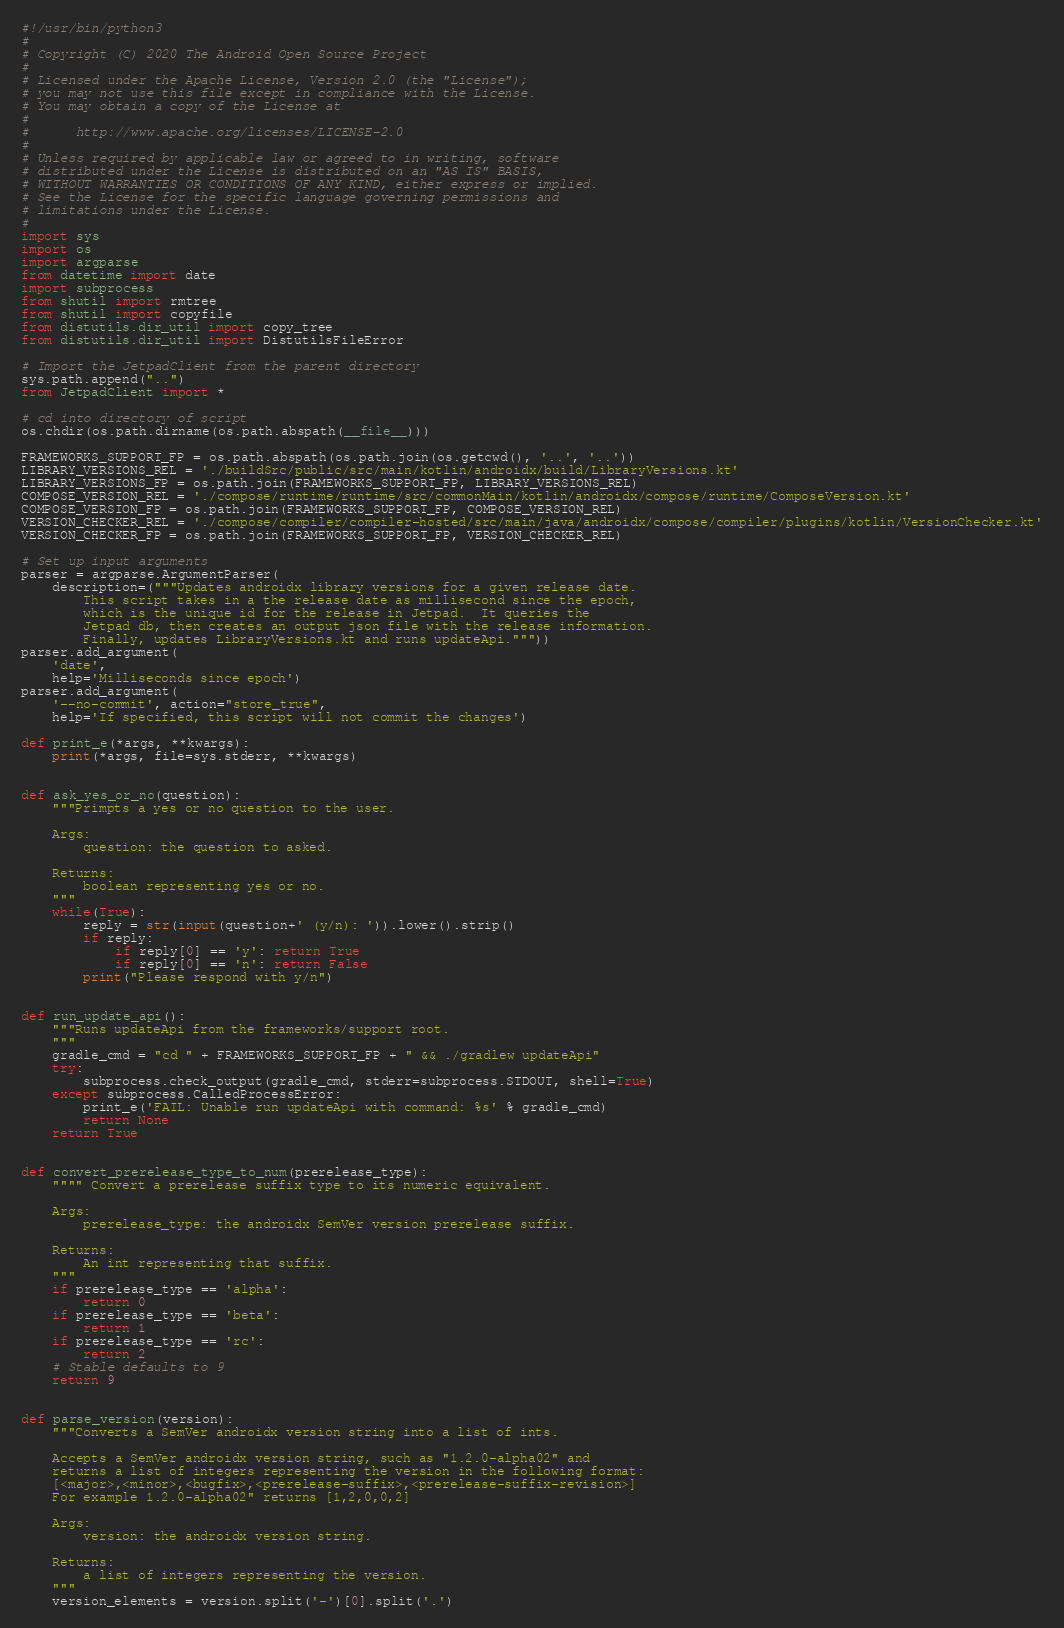Convert code to text. <code><loc_0><loc_0><loc_500><loc_500><_Python_>#!/usr/bin/python3
#
# Copyright (C) 2020 The Android Open Source Project
#
# Licensed under the Apache License, Version 2.0 (the "License");
# you may not use this file except in compliance with the License.
# You may obtain a copy of the License at
#
#      http://www.apache.org/licenses/LICENSE-2.0
#
# Unless required by applicable law or agreed to in writing, software
# distributed under the License is distributed on an "AS IS" BASIS,
# WITHOUT WARRANTIES OR CONDITIONS OF ANY KIND, either express or implied.
# See the License for the specific language governing permissions and
# limitations under the License.
#
import sys
import os
import argparse
from datetime import date
import subprocess
from shutil import rmtree
from shutil import copyfile
from distutils.dir_util import copy_tree
from distutils.dir_util import DistutilsFileError

# Import the JetpadClient from the parent directory
sys.path.append("..")
from JetpadClient import *

# cd into directory of script
os.chdir(os.path.dirname(os.path.abspath(__file__)))

FRAMEWORKS_SUPPORT_FP = os.path.abspath(os.path.join(os.getcwd(), '..', '..'))
LIBRARY_VERSIONS_REL = './buildSrc/public/src/main/kotlin/androidx/build/LibraryVersions.kt'
LIBRARY_VERSIONS_FP = os.path.join(FRAMEWORKS_SUPPORT_FP, LIBRARY_VERSIONS_REL)
COMPOSE_VERSION_REL = './compose/runtime/runtime/src/commonMain/kotlin/androidx/compose/runtime/ComposeVersion.kt'
COMPOSE_VERSION_FP = os.path.join(FRAMEWORKS_SUPPORT_FP, COMPOSE_VERSION_REL)
VERSION_CHECKER_REL = './compose/compiler/compiler-hosted/src/main/java/androidx/compose/compiler/plugins/kotlin/VersionChecker.kt'
VERSION_CHECKER_FP = os.path.join(FRAMEWORKS_SUPPORT_FP, VERSION_CHECKER_REL)

# Set up input arguments
parser = argparse.ArgumentParser(
    description=("""Updates androidx library versions for a given release date.
        This script takes in a the release date as millisecond since the epoch,
        which is the unique id for the release in Jetpad.  It queries the
        Jetpad db, then creates an output json file with the release information.
        Finally, updates LibraryVersions.kt and runs updateApi."""))
parser.add_argument(
    'date',
    help='Milliseconds since epoch')
parser.add_argument(
    '--no-commit', action="store_true",
    help='If specified, this script will not commit the changes')

def print_e(*args, **kwargs):
    print(*args, file=sys.stderr, **kwargs)


def ask_yes_or_no(question):
    """Primpts a yes or no question to the user.

    Args:
        question: the question to asked.

    Returns:
        boolean representing yes or no.
    """
    while(True):
        reply = str(input(question+' (y/n): ')).lower().strip()
        if reply:
            if reply[0] == 'y': return True
            if reply[0] == 'n': return False
        print("Please respond with y/n")


def run_update_api():
    """Runs updateApi from the frameworks/support root.
    """
    gradle_cmd = "cd " + FRAMEWORKS_SUPPORT_FP + " && ./gradlew updateApi"
    try:
        subprocess.check_output(gradle_cmd, stderr=subprocess.STDOUT, shell=True)
    except subprocess.CalledProcessError:
        print_e('FAIL: Unable run updateApi with command: %s' % gradle_cmd)
        return None
    return True


def convert_prerelease_type_to_num(prerelease_type):
    """" Convert a prerelease suffix type to its numeric equivalent.

    Args:
        prerelease_type: the androidx SemVer version prerelease suffix.

    Returns:
        An int representing that suffix.
    """
    if prerelease_type == 'alpha':
        return 0
    if prerelease_type == 'beta':
        return 1
    if prerelease_type == 'rc':
        return 2
    # Stable defaults to 9
    return 9


def parse_version(version):
    """Converts a SemVer androidx version string into a list of ints.

    Accepts a SemVer androidx version string, such as "1.2.0-alpha02" and
    returns a list of integers representing the version in the following format:
    [<major>,<minor>,<bugfix>,<prerelease-suffix>,<prerelease-suffix-revision>]
    For example 1.2.0-alpha02" returns [1,2,0,0,2]

    Args:
        version: the androidx version string.

    Returns:
        a list of integers representing the version.
    """
    version_elements = version.split('-')[0].split('.')</code> 